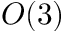<formula> <loc_0><loc_0><loc_500><loc_500>O ( 3 )</formula> 